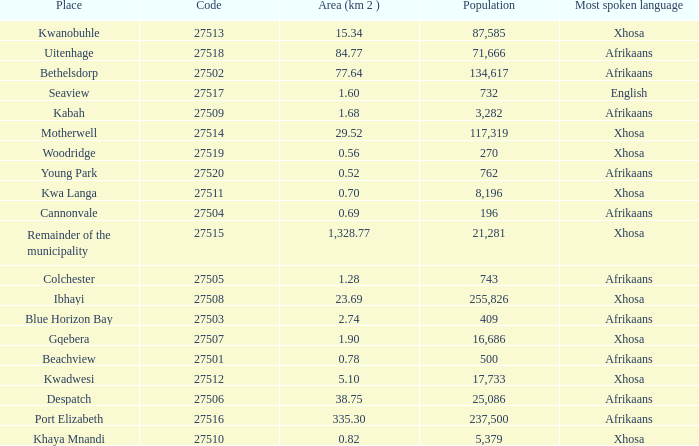What is the place that speaks xhosa, has a population less than 87,585, an area smaller than 1.28 squared kilometers, and a code larger than 27504? Khaya Mnandi, Kwa Langa, Woodridge. 